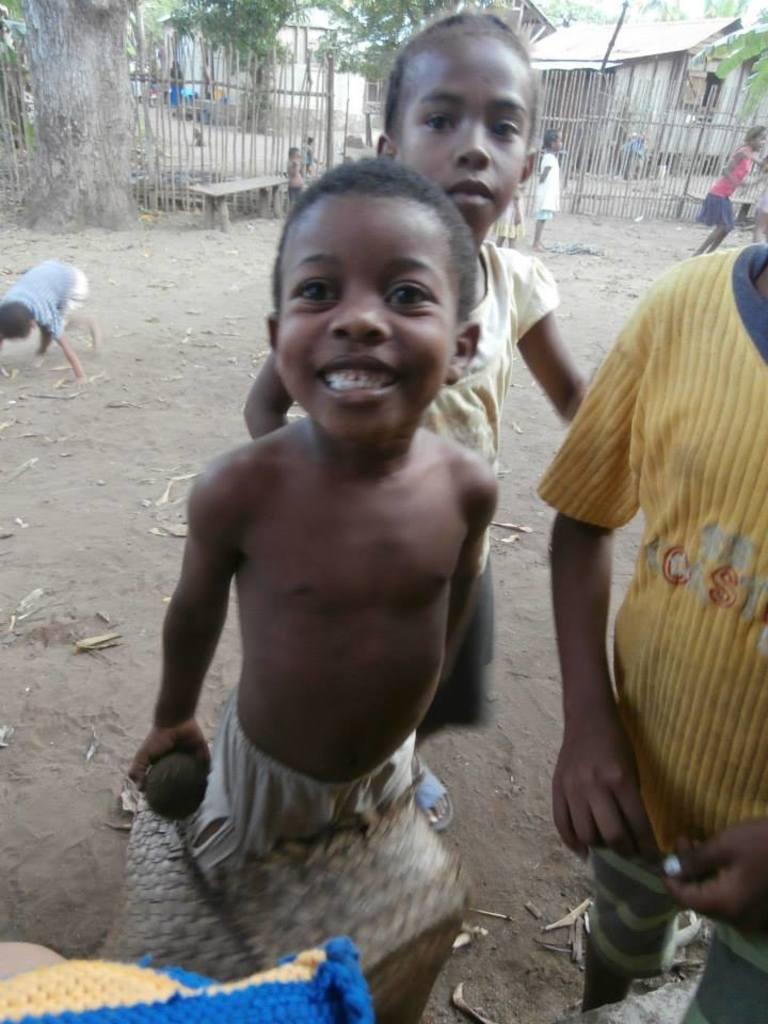How many people are in the image? There are people in the image, but the exact number is not specified. What are the people doing in the image? The people are standing and playing on a surface. What is the person holding in the image? One person is holding an object. What can be seen in the background of the image? There is a wooden fence, trees, and houses in the background of the image. What type of secretary can be seen working in the image? There is no secretary present in the image. How many girls are playing in the image? The number of girls in the image is not specified, and the term "girls" is not mentioned in the facts. 